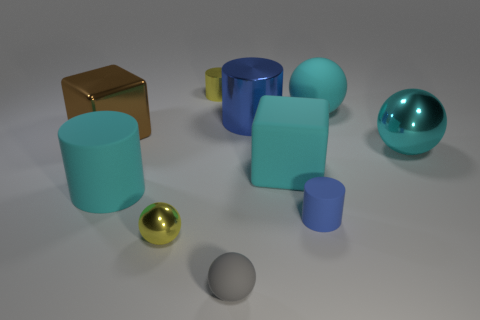Subtract all yellow spheres. Subtract all yellow cubes. How many spheres are left? 3 Subtract all spheres. How many objects are left? 6 Add 5 yellow metal things. How many yellow metal things exist? 7 Subtract 1 cyan cylinders. How many objects are left? 9 Subtract all tiny yellow rubber blocks. Subtract all metal blocks. How many objects are left? 9 Add 8 tiny yellow balls. How many tiny yellow balls are left? 9 